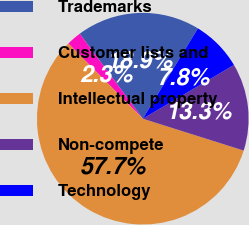Convert chart. <chart><loc_0><loc_0><loc_500><loc_500><pie_chart><fcel>Trademarks<fcel>Customer lists and<fcel>Intellectual property<fcel>Non-compete<fcel>Technology<nl><fcel>18.89%<fcel>2.26%<fcel>57.71%<fcel>13.35%<fcel>7.8%<nl></chart> 